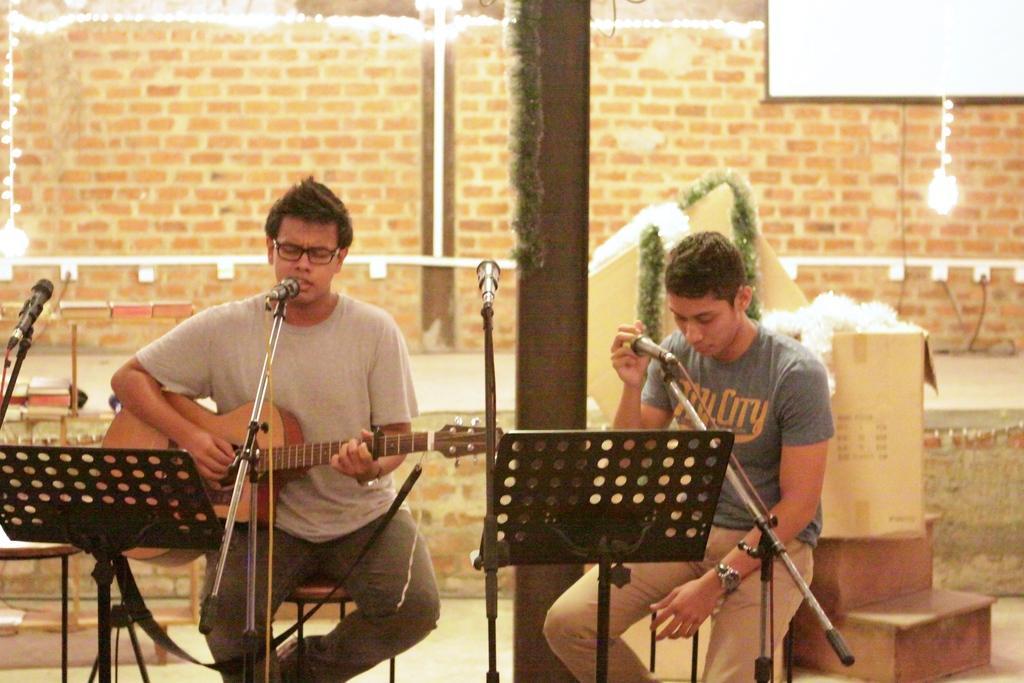Can you describe this image briefly? In this image there are two persons, one is sitting and playing guitar and he is singing, the person is sitting and holding microphone. At the back there are cardboard box, at the front there are microphones, at the back there is a wall, at the top there are lights. 